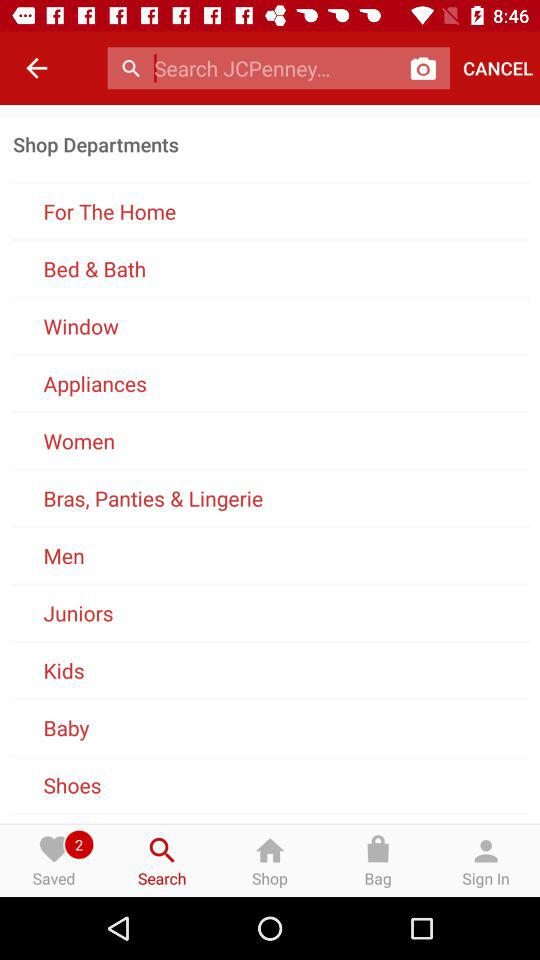How many unread notifications are there? There are 2 unread notifications. 